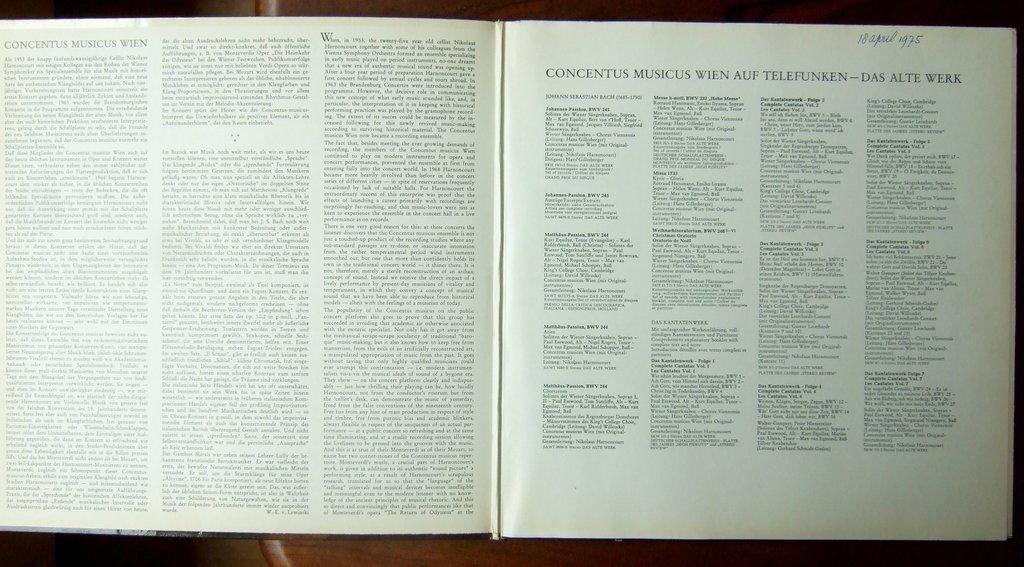<image>
Offer a succinct explanation of the picture presented. The date April 18, 1975 is hand written in the corner of a book. 